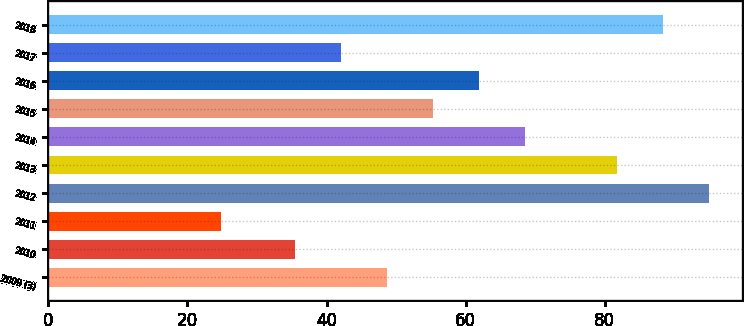Convert chart. <chart><loc_0><loc_0><loc_500><loc_500><bar_chart><fcel>2009 (3)<fcel>2010<fcel>2011<fcel>2012<fcel>2013<fcel>2014<fcel>2015<fcel>2016<fcel>2017<fcel>2018<nl><fcel>48.73<fcel>35.53<fcel>24.82<fcel>94.93<fcel>81.73<fcel>68.53<fcel>55.33<fcel>61.93<fcel>42.13<fcel>88.33<nl></chart> 